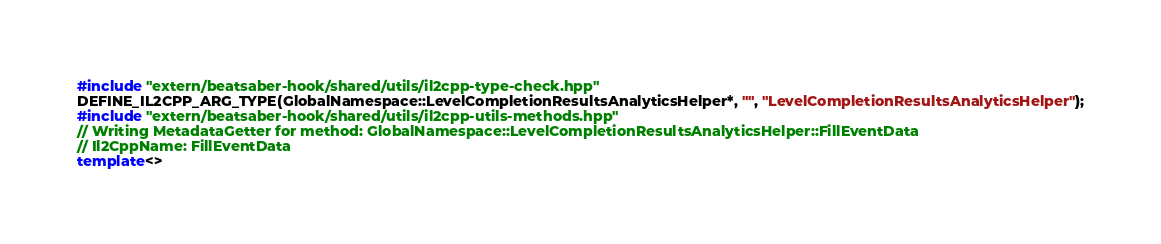<code> <loc_0><loc_0><loc_500><loc_500><_C++_>#include "extern/beatsaber-hook/shared/utils/il2cpp-type-check.hpp"
DEFINE_IL2CPP_ARG_TYPE(GlobalNamespace::LevelCompletionResultsAnalyticsHelper*, "", "LevelCompletionResultsAnalyticsHelper");
#include "extern/beatsaber-hook/shared/utils/il2cpp-utils-methods.hpp"
// Writing MetadataGetter for method: GlobalNamespace::LevelCompletionResultsAnalyticsHelper::FillEventData
// Il2CppName: FillEventData
template<></code> 